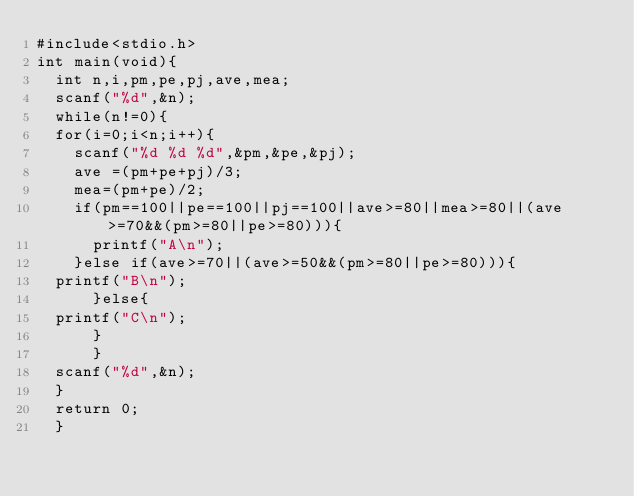<code> <loc_0><loc_0><loc_500><loc_500><_C_>#include<stdio.h>
int main(void){
  int n,i,pm,pe,pj,ave,mea;
  scanf("%d",&n);
  while(n!=0){
  for(i=0;i<n;i++){
    scanf("%d %d %d",&pm,&pe,&pj);
    ave =(pm+pe+pj)/3;
    mea=(pm+pe)/2;
    if(pm==100||pe==100||pj==100||ave>=80||mea>=80||(ave>=70&&(pm>=80||pe>=80))){
      printf("A\n");
    }else if(ave>=70||(ave>=50&&(pm>=80||pe>=80))){
	printf("B\n");
      }else{
	printf("C\n");
      }
      }
  scanf("%d",&n);
  }
  return 0;
  }

</code> 